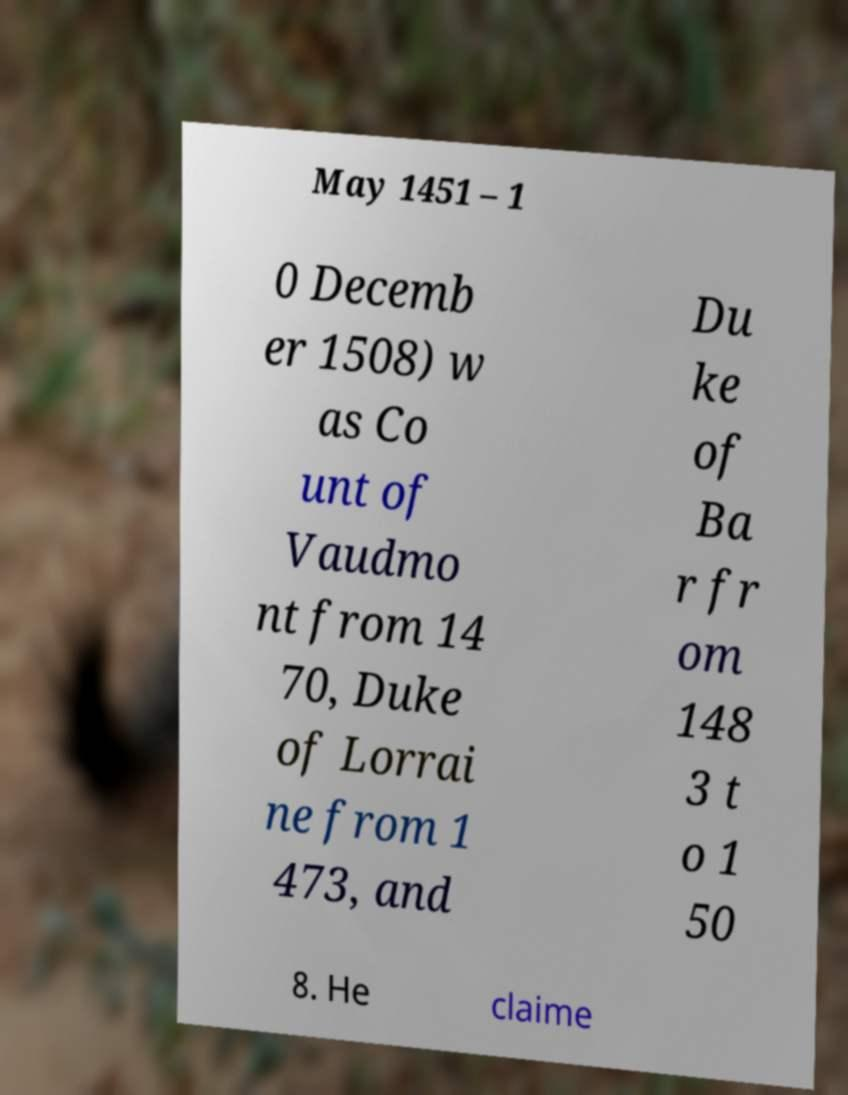For documentation purposes, I need the text within this image transcribed. Could you provide that? May 1451 – 1 0 Decemb er 1508) w as Co unt of Vaudmo nt from 14 70, Duke of Lorrai ne from 1 473, and Du ke of Ba r fr om 148 3 t o 1 50 8. He claime 